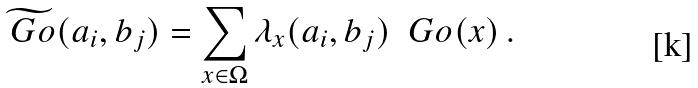<formula> <loc_0><loc_0><loc_500><loc_500>\widetilde { \ G o } ( a _ { i } , b _ { j } ) = \sum _ { x \in \Omega } \lambda _ { x } ( a _ { i } , b _ { j } ) \ \ G o ( x ) \, .</formula> 